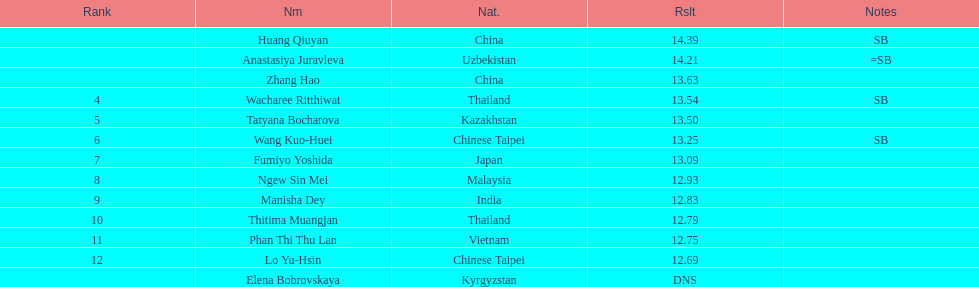Which country came in first? China. 